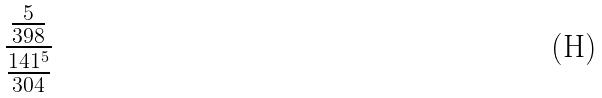<formula> <loc_0><loc_0><loc_500><loc_500>\frac { \frac { 5 } { 3 9 8 } } { \frac { 1 4 1 ^ { 5 } } { 3 0 4 } }</formula> 